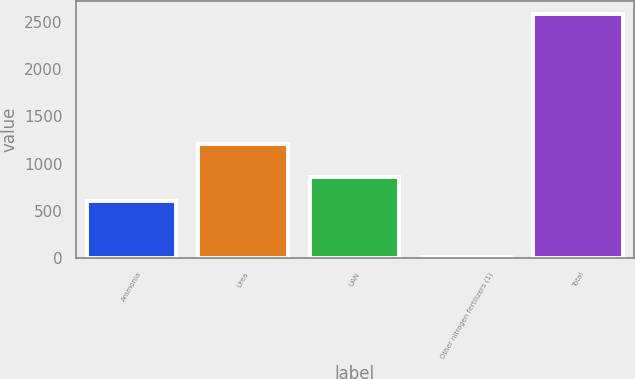<chart> <loc_0><loc_0><loc_500><loc_500><bar_chart><fcel>Ammonia<fcel>Urea<fcel>UAN<fcel>Other nitrogen fertilizers (1)<fcel>Total<nl><fcel>604.1<fcel>1208.3<fcel>862.6<fcel>6.1<fcel>2591.1<nl></chart> 